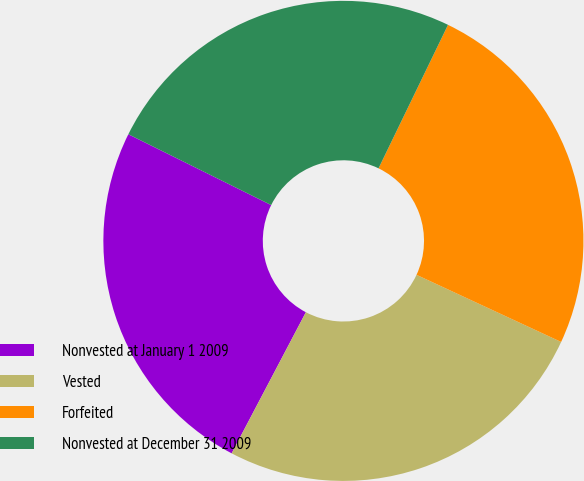Convert chart to OTSL. <chart><loc_0><loc_0><loc_500><loc_500><pie_chart><fcel>Nonvested at January 1 2009<fcel>Vested<fcel>Forfeited<fcel>Nonvested at December 31 2009<nl><fcel>24.62%<fcel>25.79%<fcel>24.74%<fcel>24.85%<nl></chart> 